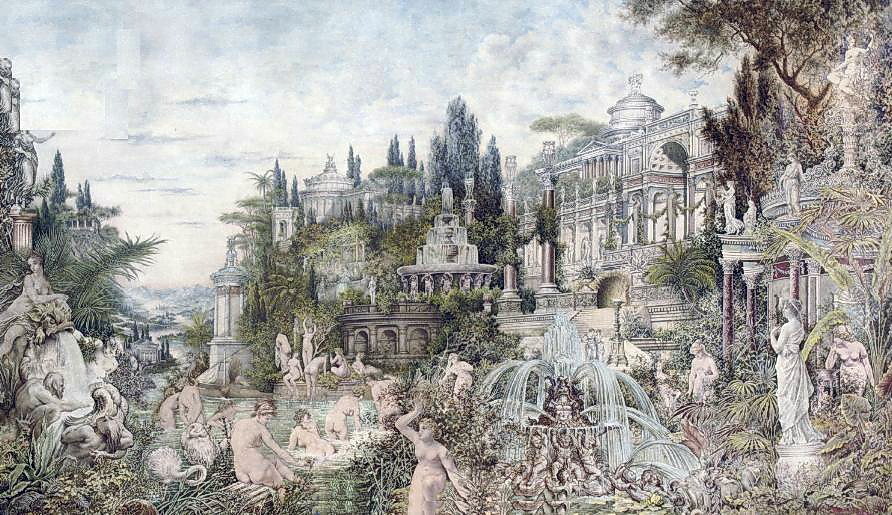What era does the palace in the image draw inspiration from? The architectural design of the palace in the image appears to be inspired by the Rococo era, which flourished in the early to mid-18th century. This period is known for its ornate and decorative style, characterized by intricate details, elaborate ornamentation, and graceful, often playful, aesthetic elements. The lavishness and elegance depicted in the palace's structure are exemplary of Rococo influence. Can you explain the significance of the statues and fountains in the garden? The statues and fountains in the garden play a crucial role in enhancing the overall aesthetic and thematic depth of the image. Statues often serve as symbolic elements, representing mythological figures, historical personas, or embodying abstract ideas like beauty, strength, or wisdom. In this landscape, the statues are crafted with meticulous detail, adding a classical and timeless appeal to the setting.

Fountains, on the other hand, introduce a dynamic component to the scene. The flowing water adds movement and life, creating an interplay of light and reflections that enrich the visual experience. Fountains often symbolize abundance, renewal, and the harmonious balance between human creation and natural elements. Together, these features contribute to the image's enchanting and tranquil atmosphere, making the garden a place of contemplation and wonder. Imagine if this scene came to life. What kind of story might unfold in this setting? Imagine a timeless tale where the palace gardens come alive with whispers of forgotten legends. As twilight descends, the statues, carved with lifelike precision, begin to move, stepping gracefully from their pedestals. Amid the soft glow of moonlight, they gather around the fountains, where water seems to dance to an ethereal melody.

In this enchanted realm, the palace hosts an annual celebration, a grand masquerade where mythical beings and mortals alike don ornate masks and gowns. This event is steeped in tradition, honoring an ancient pact between the realm of humans and the mystical entities that guard the land.

As guests arrive, the air buzzes with excitement and magic. The fountains' water transforms into shimmering cascades of light, guiding the visitors through the labyrinthine gardens. Whispers of intrigue and romance fill the air as couples stroll beneath archways draped in aromatic flowers, while scholars and adventurers share tales of lost knowledge and hidden treasures.

At the heart of the palace, in a grand ballroom, dances unfold in a mesmerizing display of grace and elegance. The night reaches its zenith when the revered monarch makes an appearance, a figure of regal beauty, whose presence symbolizes the unity and harmony between the natural and fantastical worlds.

As dawn approaches, the magical beings return to their stone forms, the fountains' light subsides, and the garden slips back into its serene tranquility, leaving only the faintest trace of magic in the air, a memory of a night where dreams and reality intertwined. 